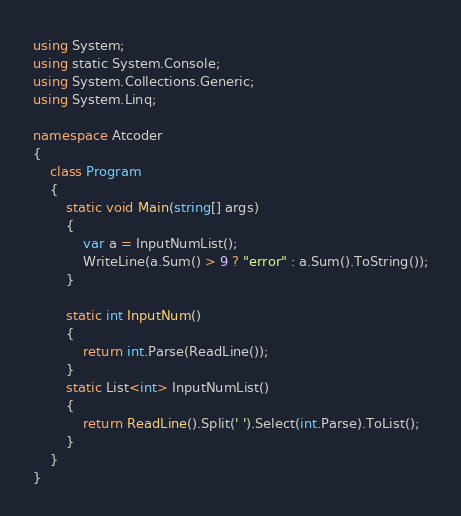Convert code to text. <code><loc_0><loc_0><loc_500><loc_500><_C#_>using System;
using static System.Console;
using System.Collections.Generic;
using System.Linq;

namespace Atcoder
{
    class Program
    {
        static void Main(string[] args)
        {
            var a = InputNumList();
            WriteLine(a.Sum() > 9 ? "error" : a.Sum().ToString());
        }

        static int InputNum()
        {
            return int.Parse(ReadLine());
        }
        static List<int> InputNumList()
        {
            return ReadLine().Split(' ').Select(int.Parse).ToList();
        }
    }
}

</code> 